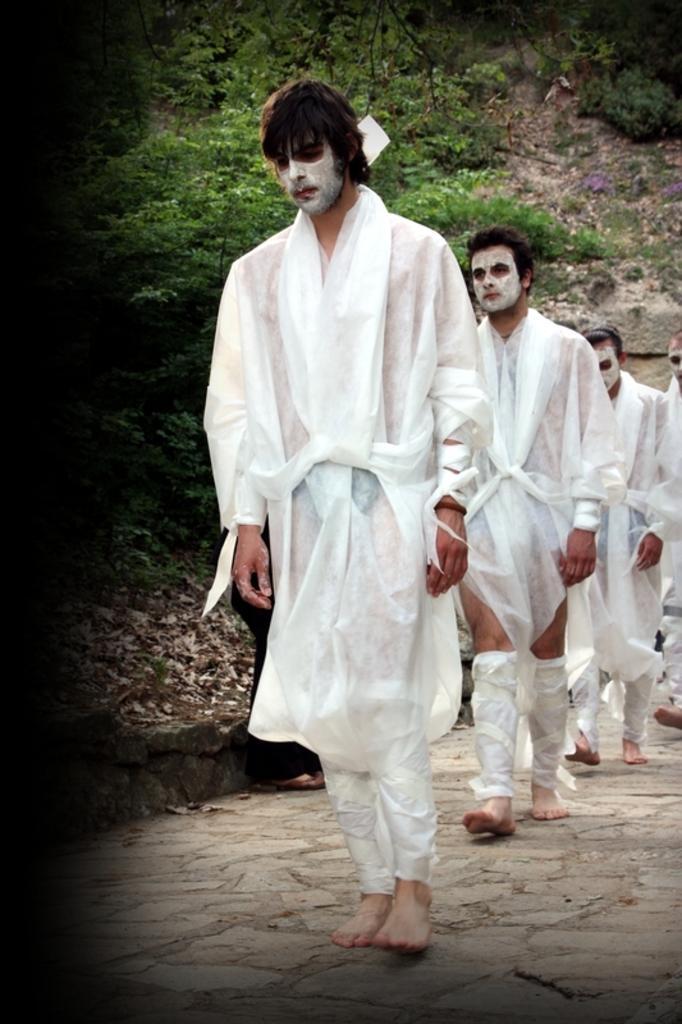How would you summarize this image in a sentence or two? In this picture there are few persons standing and wearing white dress and a white paint on their face and there are few trees in the background. 